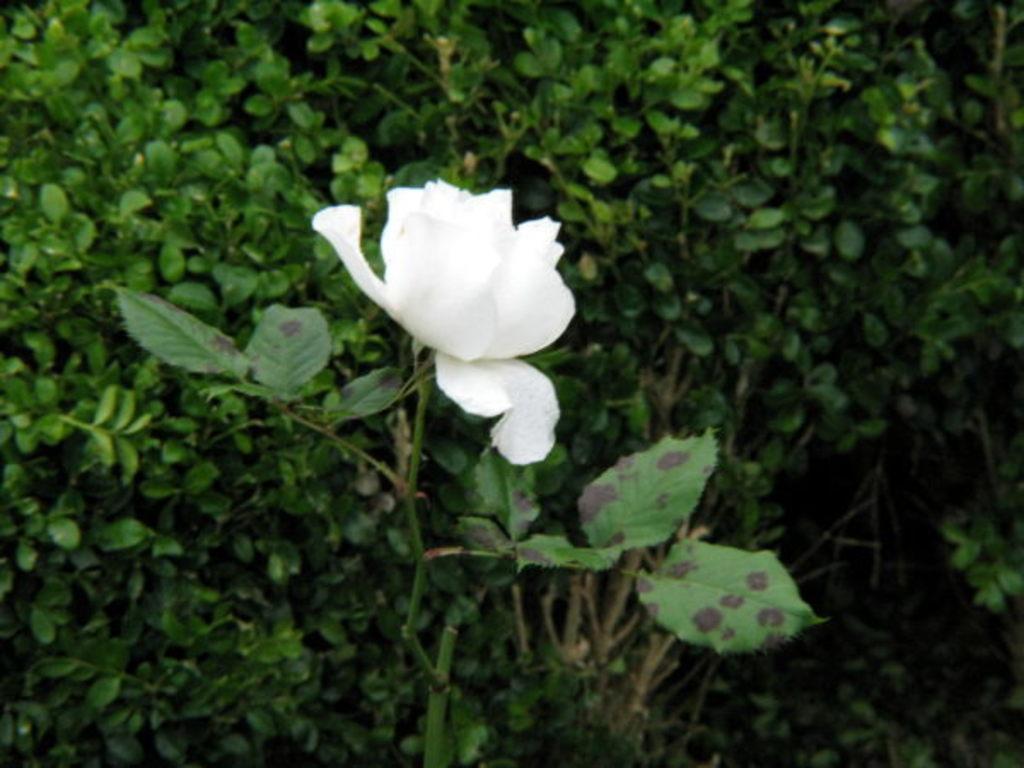Could you give a brief overview of what you see in this image? In this picture we can see white color flower to the plant, around we can see some plants. 